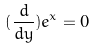<formula> <loc_0><loc_0><loc_500><loc_500>( \frac { d } { d y } ) e ^ { x } = 0</formula> 